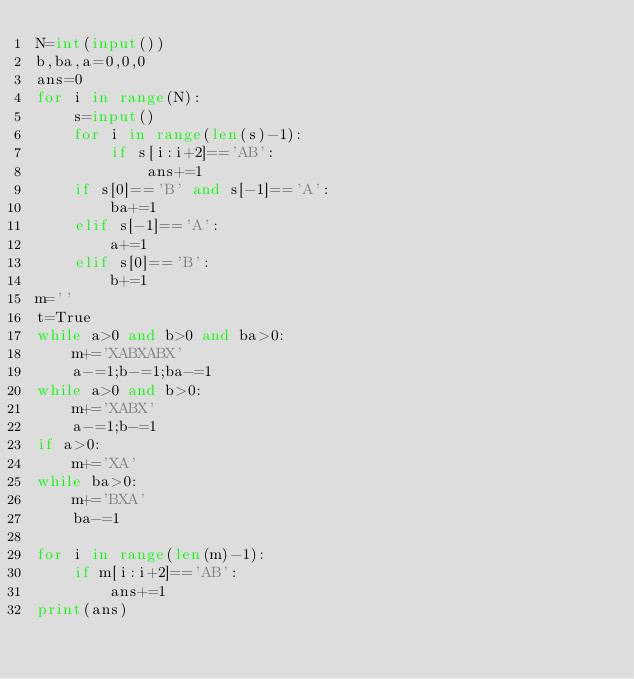<code> <loc_0><loc_0><loc_500><loc_500><_Python_>N=int(input())
b,ba,a=0,0,0
ans=0
for i in range(N):
    s=input()
    for i in range(len(s)-1):
        if s[i:i+2]=='AB':
            ans+=1
    if s[0]=='B' and s[-1]=='A':
        ba+=1
    elif s[-1]=='A':
        a+=1
    elif s[0]=='B':
        b+=1
m=''
t=True
while a>0 and b>0 and ba>0:
    m+='XABXABX'
    a-=1;b-=1;ba-=1
while a>0 and b>0:
    m+='XABX'
    a-=1;b-=1
if a>0:
    m+='XA'
while ba>0:
    m+='BXA'
    ba-=1
    
for i in range(len(m)-1):
    if m[i:i+2]=='AB':
        ans+=1
print(ans)</code> 